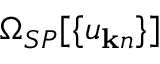Convert formula to latex. <formula><loc_0><loc_0><loc_500><loc_500>\Omega _ { S P } [ \{ u _ { { k } n } \} ]</formula> 